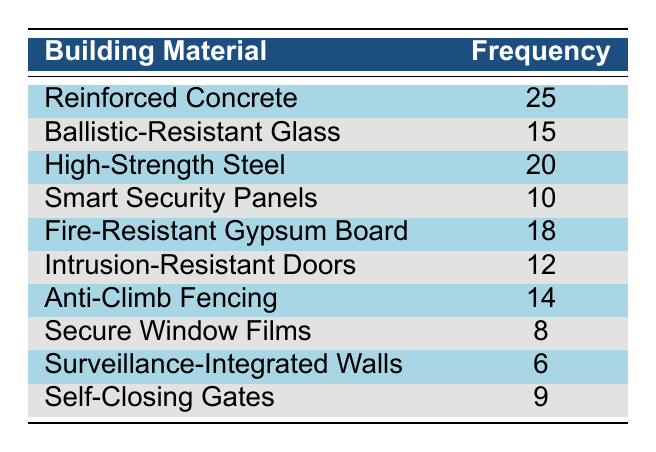What is the most frequently used building material in the projects? The most frequently used material is located in the row with the highest frequency value. By scanning the frequencies, Reinforced Concrete has the highest frequency of 25.
Answer: 25 How many materials have a frequency of 15 or more? To answer this, we count all materials whose frequency is greater than or equal to 15. The eligible materials are: Reinforced Concrete (25), High-Strength Steel (20), Ballistic-Resistant Glass (15), Fire-Resistant Gypsum Board (18), Anti-Climb Fencing (14), Intrusion-Resistant Doors (12). Hence, five materials meet this criteria.
Answer: 6 What is the total frequency of all building materials used? We sum all the frequency values listed in the table. The sum is: 25 + 15 + 20 + 10 + 18 + 12 + 14 + 8 + 6 + 9 =  25 + 15 = 40, 40 + 20 = 60, 60 + 10 = 70, 70 + 18 = 88, 88 + 12 = 100, 100 + 14 = 114, 114 + 8 = 122, 122 + 6 = 128, and finally 128 + 9 = 137.
Answer: 137 Is Anti-Climb Fencing used more frequently than Smart Security Panels? We directly compare the frequencies of the two materials. Anti-Climb Fencing has a frequency of 14 while Smart Security Panels have a frequency of 10. Since 14 is indeed greater than 10, the answer is yes.
Answer: Yes What is the difference in frequency between the most and least frequently used materials? We find the most and least frequently used materials, which are Reinforced Concrete (25) and Surveillance-Integrated Walls (6), respectively. The difference is calculated by subtracting the frequency of the least used material from the most used one: 25 - 6 = 19.
Answer: 19 How many materials have a frequency lower than 10? We check each material's frequency and count how many are below 10. The materials Secure Window Films (8) and Surveillance-Integrated Walls (6) both have frequencies under 10, making the total count 2.
Answer: 2 What is the average frequency of all the building materials listed in the table? To find the average, we divide the total frequency (137) by the number of materials (10). So, the average frequency is calculated as 137 / 10 = 13.7.
Answer: 13.7 Is the frequency of Fire-Resistant Gypsum Board greater than High-Strength Steel? We can compare the two frequencies directly from the table. Fire-Resistant Gypsum Board has a frequency of 18, while High-Strength Steel has a frequency of 20. Since 18 is less than 20, the answer is no.
Answer: No How many more times is Reinforced Concrete used compared to Secure Window Films? The frequencies for Reinforced Concrete and Secure Window Films are as follows: Reinforced Concrete (25) and Secure Window Films (8). We calculate the ratio by dividing the frequency of Reinforced Concrete by that of Secure Window Films: 25 / 8 = 3.125, meaning that Reinforced Concrete is used approximately 3.125 times more than Secure Window Films.
Answer: 3.125 